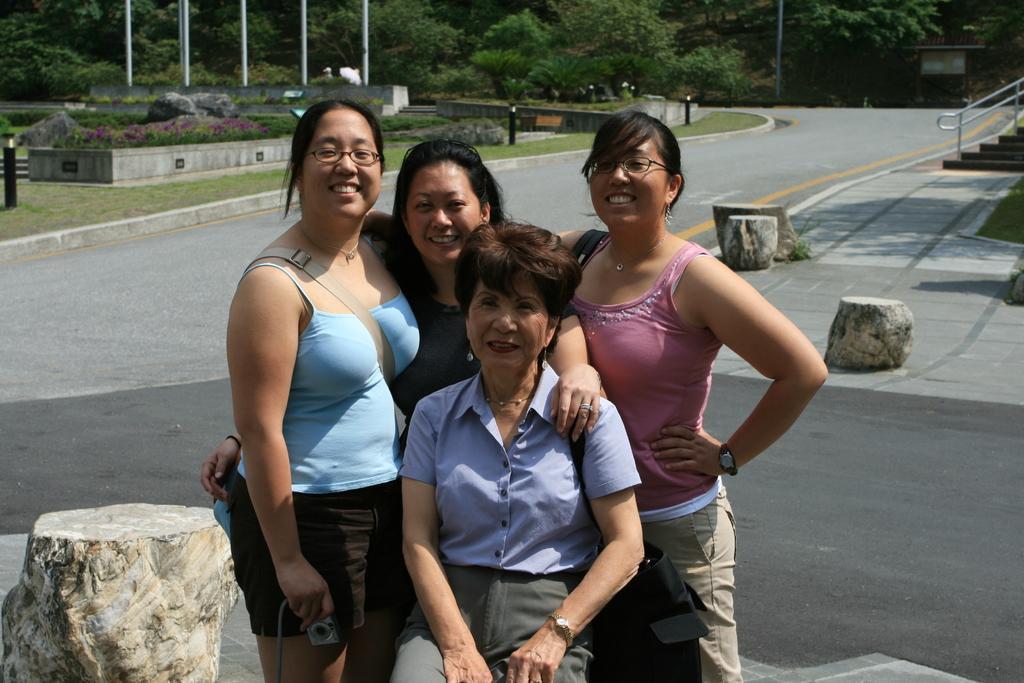Can you describe this image briefly? In this image I can see group of women among them one woman is sitting and other women are standing. These women are smiling. In the background I can see a road, the grass, poles and trees. Here I can see stairs and some wooden objects. 